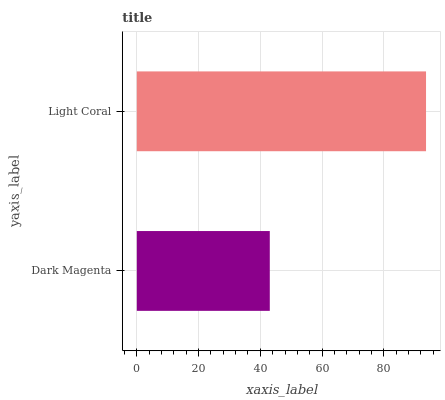Is Dark Magenta the minimum?
Answer yes or no. Yes. Is Light Coral the maximum?
Answer yes or no. Yes. Is Light Coral the minimum?
Answer yes or no. No. Is Light Coral greater than Dark Magenta?
Answer yes or no. Yes. Is Dark Magenta less than Light Coral?
Answer yes or no. Yes. Is Dark Magenta greater than Light Coral?
Answer yes or no. No. Is Light Coral less than Dark Magenta?
Answer yes or no. No. Is Light Coral the high median?
Answer yes or no. Yes. Is Dark Magenta the low median?
Answer yes or no. Yes. Is Dark Magenta the high median?
Answer yes or no. No. Is Light Coral the low median?
Answer yes or no. No. 